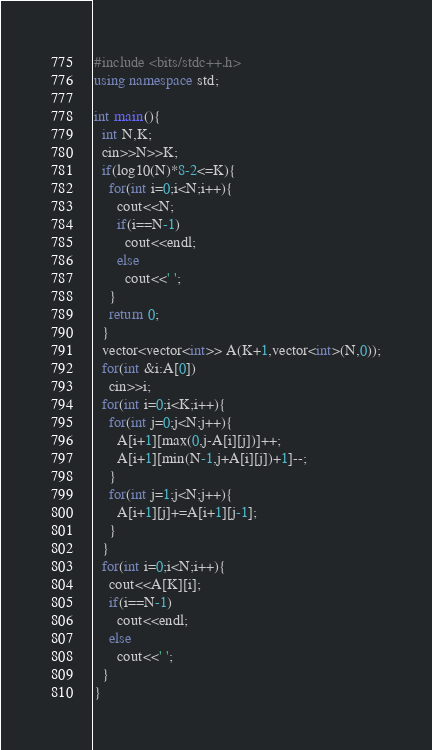Convert code to text. <code><loc_0><loc_0><loc_500><loc_500><_C++_>#include <bits/stdc++.h>
using namespace std;
 
int main(){
  int N,K;
  cin>>N>>K;
  if(log10(N)*8-2<=K){
    for(int i=0;i<N;i++){
      cout<<N;
      if(i==N-1)
        cout<<endl;
      else
        cout<<' ';
    }
    return 0;
  }
  vector<vector<int>> A(K+1,vector<int>(N,0));
  for(int &i:A[0])
    cin>>i;
  for(int i=0;i<K;i++){
    for(int j=0;j<N;j++){
      A[i+1][max(0,j-A[i][j])]++;
      A[i+1][min(N-1,j+A[i][j])+1]--;
    }
    for(int j=1;j<N;j++){
      A[i+1][j]+=A[i+1][j-1];
    }
  }
  for(int i=0;i<N;i++){
    cout<<A[K][i];
    if(i==N-1)
      cout<<endl;
    else
      cout<<' ';
  }
}</code> 